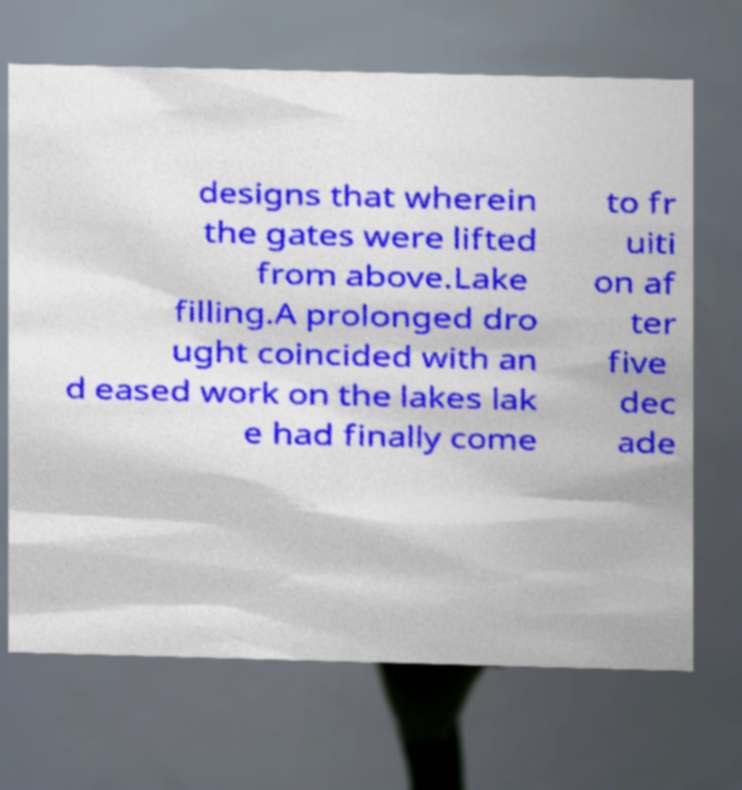Please read and relay the text visible in this image. What does it say? designs that wherein the gates were lifted from above.Lake filling.A prolonged dro ught coincided with an d eased work on the lakes lak e had finally come to fr uiti on af ter five dec ade 